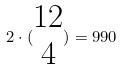<formula> <loc_0><loc_0><loc_500><loc_500>2 \cdot ( \begin{matrix} 1 2 \\ 4 \end{matrix} ) = 9 9 0</formula> 